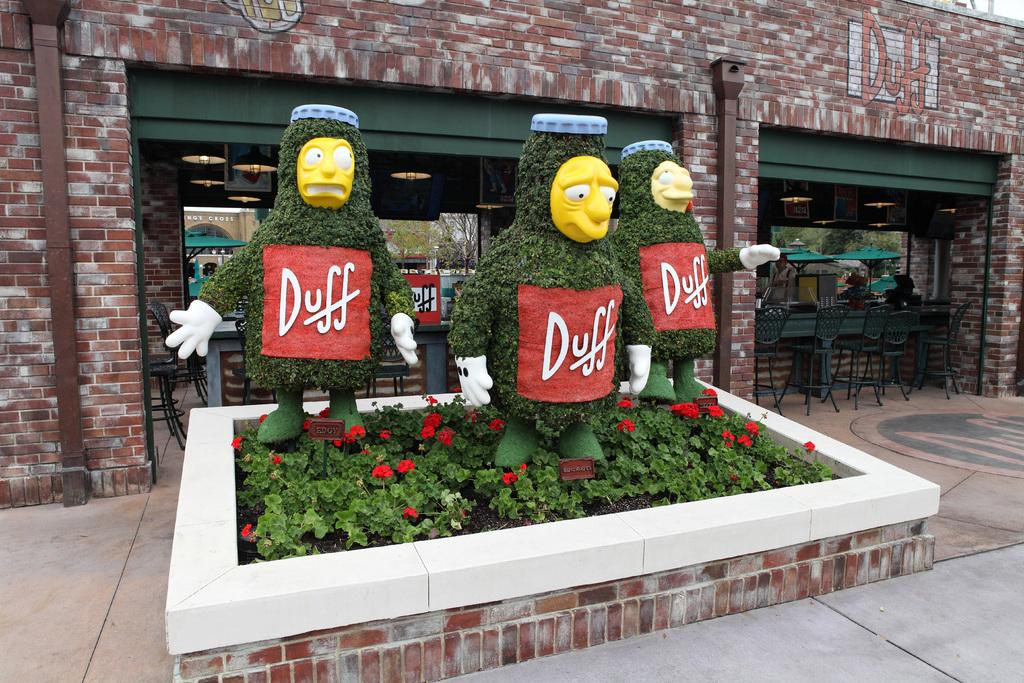<image>
Present a compact description of the photo's key features. A small garden with hedges cut to look like Duff beer men from The Simpsons. 